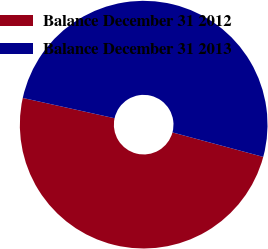<chart> <loc_0><loc_0><loc_500><loc_500><pie_chart><fcel>Balance December 31 2012<fcel>Balance December 31 2013<nl><fcel>49.27%<fcel>50.73%<nl></chart> 